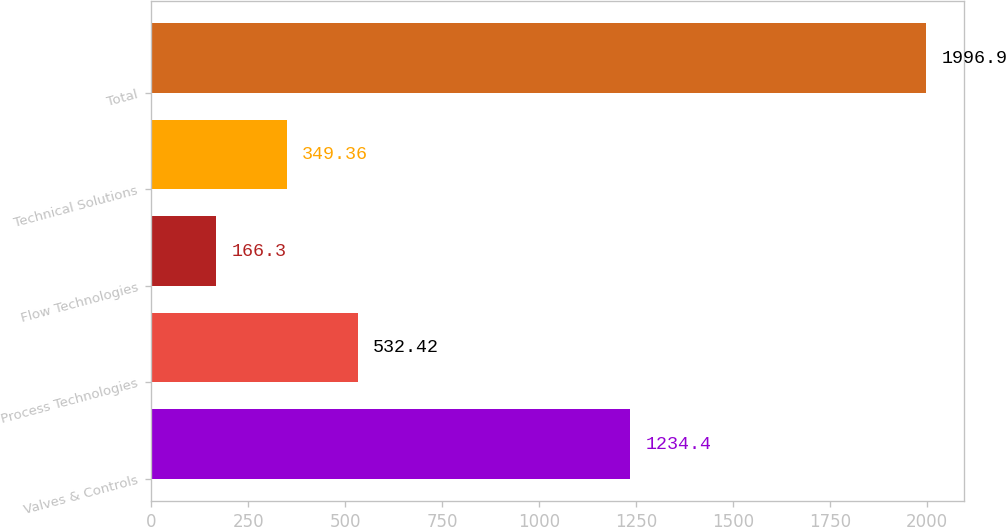Convert chart to OTSL. <chart><loc_0><loc_0><loc_500><loc_500><bar_chart><fcel>Valves & Controls<fcel>Process Technologies<fcel>Flow Technologies<fcel>Technical Solutions<fcel>Total<nl><fcel>1234.4<fcel>532.42<fcel>166.3<fcel>349.36<fcel>1996.9<nl></chart> 